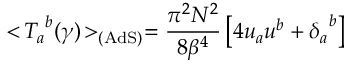Convert formula to latex. <formula><loc_0><loc_0><loc_500><loc_500>< \, { { T } _ { a } } ^ { b } ( \gamma ) \, > _ { ( A d S ) } = { \frac { \pi ^ { 2 } N ^ { 2 } } { 8 { \beta } ^ { 4 } } } \left [ 4 u _ { a } u ^ { b } + { { \delta } _ { a } } ^ { b } \right ]</formula> 